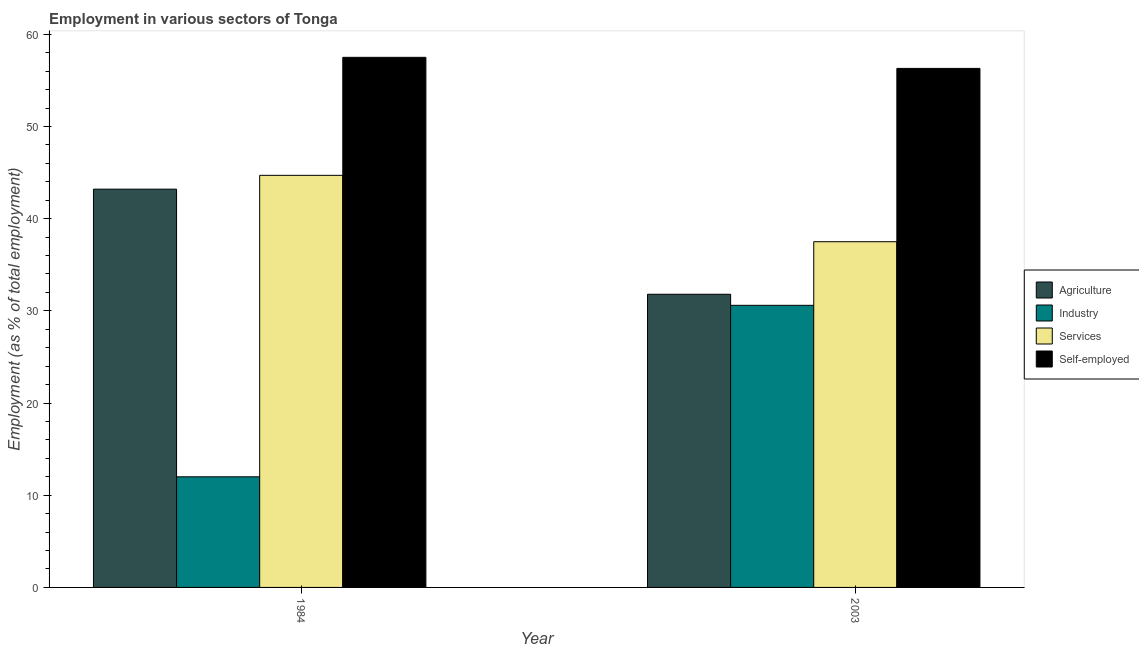How many different coloured bars are there?
Offer a terse response. 4. Are the number of bars on each tick of the X-axis equal?
Offer a very short reply. Yes. How many bars are there on the 1st tick from the left?
Offer a very short reply. 4. What is the label of the 1st group of bars from the left?
Offer a very short reply. 1984. In how many cases, is the number of bars for a given year not equal to the number of legend labels?
Your answer should be compact. 0. What is the percentage of workers in services in 1984?
Your answer should be very brief. 44.7. Across all years, what is the maximum percentage of workers in agriculture?
Provide a succinct answer. 43.2. Across all years, what is the minimum percentage of workers in agriculture?
Offer a very short reply. 31.8. In which year was the percentage of self employed workers maximum?
Offer a very short reply. 1984. What is the total percentage of self employed workers in the graph?
Give a very brief answer. 113.8. What is the difference between the percentage of self employed workers in 1984 and that in 2003?
Give a very brief answer. 1.2. What is the difference between the percentage of workers in agriculture in 2003 and the percentage of workers in industry in 1984?
Your answer should be very brief. -11.4. What is the average percentage of workers in industry per year?
Offer a terse response. 21.3. In the year 2003, what is the difference between the percentage of workers in industry and percentage of self employed workers?
Offer a terse response. 0. In how many years, is the percentage of workers in agriculture greater than 4 %?
Give a very brief answer. 2. What is the ratio of the percentage of workers in agriculture in 1984 to that in 2003?
Offer a very short reply. 1.36. Is the percentage of workers in agriculture in 1984 less than that in 2003?
Your answer should be very brief. No. In how many years, is the percentage of workers in agriculture greater than the average percentage of workers in agriculture taken over all years?
Provide a short and direct response. 1. Is it the case that in every year, the sum of the percentage of workers in industry and percentage of self employed workers is greater than the sum of percentage of workers in agriculture and percentage of workers in services?
Ensure brevity in your answer.  Yes. What does the 2nd bar from the left in 1984 represents?
Offer a terse response. Industry. What does the 4th bar from the right in 2003 represents?
Provide a short and direct response. Agriculture. Is it the case that in every year, the sum of the percentage of workers in agriculture and percentage of workers in industry is greater than the percentage of workers in services?
Offer a very short reply. Yes. How many bars are there?
Offer a terse response. 8. Are all the bars in the graph horizontal?
Provide a short and direct response. No. Are the values on the major ticks of Y-axis written in scientific E-notation?
Keep it short and to the point. No. Does the graph contain grids?
Offer a very short reply. No. How many legend labels are there?
Offer a very short reply. 4. What is the title of the graph?
Provide a succinct answer. Employment in various sectors of Tonga. Does "Argument" appear as one of the legend labels in the graph?
Make the answer very short. No. What is the label or title of the X-axis?
Make the answer very short. Year. What is the label or title of the Y-axis?
Offer a very short reply. Employment (as % of total employment). What is the Employment (as % of total employment) of Agriculture in 1984?
Provide a short and direct response. 43.2. What is the Employment (as % of total employment) in Services in 1984?
Ensure brevity in your answer.  44.7. What is the Employment (as % of total employment) of Self-employed in 1984?
Your answer should be very brief. 57.5. What is the Employment (as % of total employment) in Agriculture in 2003?
Ensure brevity in your answer.  31.8. What is the Employment (as % of total employment) in Industry in 2003?
Make the answer very short. 30.6. What is the Employment (as % of total employment) of Services in 2003?
Provide a succinct answer. 37.5. What is the Employment (as % of total employment) of Self-employed in 2003?
Your response must be concise. 56.3. Across all years, what is the maximum Employment (as % of total employment) in Agriculture?
Provide a short and direct response. 43.2. Across all years, what is the maximum Employment (as % of total employment) in Industry?
Ensure brevity in your answer.  30.6. Across all years, what is the maximum Employment (as % of total employment) of Services?
Make the answer very short. 44.7. Across all years, what is the maximum Employment (as % of total employment) in Self-employed?
Provide a succinct answer. 57.5. Across all years, what is the minimum Employment (as % of total employment) of Agriculture?
Make the answer very short. 31.8. Across all years, what is the minimum Employment (as % of total employment) of Industry?
Ensure brevity in your answer.  12. Across all years, what is the minimum Employment (as % of total employment) of Services?
Keep it short and to the point. 37.5. Across all years, what is the minimum Employment (as % of total employment) in Self-employed?
Your response must be concise. 56.3. What is the total Employment (as % of total employment) of Industry in the graph?
Provide a succinct answer. 42.6. What is the total Employment (as % of total employment) in Services in the graph?
Your answer should be very brief. 82.2. What is the total Employment (as % of total employment) of Self-employed in the graph?
Your response must be concise. 113.8. What is the difference between the Employment (as % of total employment) in Industry in 1984 and that in 2003?
Make the answer very short. -18.6. What is the difference between the Employment (as % of total employment) in Self-employed in 1984 and that in 2003?
Provide a short and direct response. 1.2. What is the difference between the Employment (as % of total employment) of Agriculture in 1984 and the Employment (as % of total employment) of Industry in 2003?
Your answer should be compact. 12.6. What is the difference between the Employment (as % of total employment) in Agriculture in 1984 and the Employment (as % of total employment) in Services in 2003?
Provide a succinct answer. 5.7. What is the difference between the Employment (as % of total employment) in Agriculture in 1984 and the Employment (as % of total employment) in Self-employed in 2003?
Your answer should be very brief. -13.1. What is the difference between the Employment (as % of total employment) in Industry in 1984 and the Employment (as % of total employment) in Services in 2003?
Make the answer very short. -25.5. What is the difference between the Employment (as % of total employment) in Industry in 1984 and the Employment (as % of total employment) in Self-employed in 2003?
Offer a terse response. -44.3. What is the difference between the Employment (as % of total employment) of Services in 1984 and the Employment (as % of total employment) of Self-employed in 2003?
Keep it short and to the point. -11.6. What is the average Employment (as % of total employment) of Agriculture per year?
Offer a very short reply. 37.5. What is the average Employment (as % of total employment) in Industry per year?
Offer a terse response. 21.3. What is the average Employment (as % of total employment) in Services per year?
Offer a very short reply. 41.1. What is the average Employment (as % of total employment) of Self-employed per year?
Keep it short and to the point. 56.9. In the year 1984, what is the difference between the Employment (as % of total employment) of Agriculture and Employment (as % of total employment) of Industry?
Your answer should be compact. 31.2. In the year 1984, what is the difference between the Employment (as % of total employment) in Agriculture and Employment (as % of total employment) in Self-employed?
Provide a short and direct response. -14.3. In the year 1984, what is the difference between the Employment (as % of total employment) of Industry and Employment (as % of total employment) of Services?
Ensure brevity in your answer.  -32.7. In the year 1984, what is the difference between the Employment (as % of total employment) of Industry and Employment (as % of total employment) of Self-employed?
Give a very brief answer. -45.5. In the year 1984, what is the difference between the Employment (as % of total employment) of Services and Employment (as % of total employment) of Self-employed?
Keep it short and to the point. -12.8. In the year 2003, what is the difference between the Employment (as % of total employment) of Agriculture and Employment (as % of total employment) of Services?
Ensure brevity in your answer.  -5.7. In the year 2003, what is the difference between the Employment (as % of total employment) in Agriculture and Employment (as % of total employment) in Self-employed?
Offer a very short reply. -24.5. In the year 2003, what is the difference between the Employment (as % of total employment) of Industry and Employment (as % of total employment) of Services?
Give a very brief answer. -6.9. In the year 2003, what is the difference between the Employment (as % of total employment) in Industry and Employment (as % of total employment) in Self-employed?
Provide a succinct answer. -25.7. In the year 2003, what is the difference between the Employment (as % of total employment) in Services and Employment (as % of total employment) in Self-employed?
Your answer should be compact. -18.8. What is the ratio of the Employment (as % of total employment) in Agriculture in 1984 to that in 2003?
Your answer should be very brief. 1.36. What is the ratio of the Employment (as % of total employment) of Industry in 1984 to that in 2003?
Offer a terse response. 0.39. What is the ratio of the Employment (as % of total employment) of Services in 1984 to that in 2003?
Your response must be concise. 1.19. What is the ratio of the Employment (as % of total employment) in Self-employed in 1984 to that in 2003?
Your response must be concise. 1.02. What is the difference between the highest and the second highest Employment (as % of total employment) of Agriculture?
Keep it short and to the point. 11.4. What is the difference between the highest and the second highest Employment (as % of total employment) in Industry?
Give a very brief answer. 18.6. What is the difference between the highest and the second highest Employment (as % of total employment) in Self-employed?
Give a very brief answer. 1.2. What is the difference between the highest and the lowest Employment (as % of total employment) of Industry?
Provide a short and direct response. 18.6. What is the difference between the highest and the lowest Employment (as % of total employment) of Services?
Offer a terse response. 7.2. What is the difference between the highest and the lowest Employment (as % of total employment) in Self-employed?
Offer a very short reply. 1.2. 